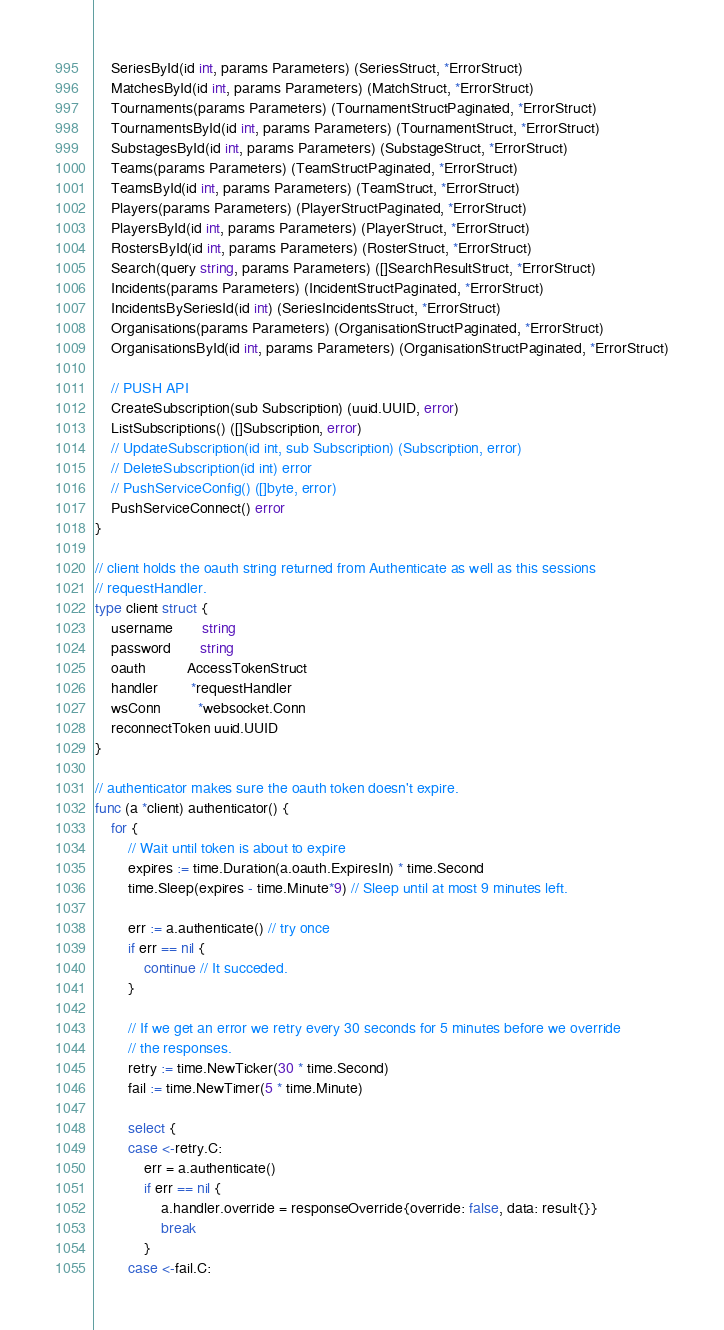<code> <loc_0><loc_0><loc_500><loc_500><_Go_>	SeriesById(id int, params Parameters) (SeriesStruct, *ErrorStruct)
	MatchesById(id int, params Parameters) (MatchStruct, *ErrorStruct)
	Tournaments(params Parameters) (TournamentStructPaginated, *ErrorStruct)
	TournamentsById(id int, params Parameters) (TournamentStruct, *ErrorStruct)
	SubstagesById(id int, params Parameters) (SubstageStruct, *ErrorStruct)
	Teams(params Parameters) (TeamStructPaginated, *ErrorStruct)
	TeamsById(id int, params Parameters) (TeamStruct, *ErrorStruct)
	Players(params Parameters) (PlayerStructPaginated, *ErrorStruct)
	PlayersById(id int, params Parameters) (PlayerStruct, *ErrorStruct)
	RostersById(id int, params Parameters) (RosterStruct, *ErrorStruct)
	Search(query string, params Parameters) ([]SearchResultStruct, *ErrorStruct)
	Incidents(params Parameters) (IncidentStructPaginated, *ErrorStruct)
	IncidentsBySeriesId(id int) (SeriesIncidentsStruct, *ErrorStruct)
	Organisations(params Parameters) (OrganisationStructPaginated, *ErrorStruct)
	OrganisationsById(id int, params Parameters) (OrganisationStructPaginated, *ErrorStruct)

	// PUSH API
	CreateSubscription(sub Subscription) (uuid.UUID, error)
	ListSubscriptions() ([]Subscription, error)
	// UpdateSubscription(id int, sub Subscription) (Subscription, error)
	// DeleteSubscription(id int) error
	// PushServiceConfig() ([]byte, error)
	PushServiceConnect() error
}

// client holds the oauth string returned from Authenticate as well as this sessions
// requestHandler.
type client struct {
	username       string
	password       string
	oauth          AccessTokenStruct
	handler        *requestHandler
	wsConn         *websocket.Conn
	reconnectToken uuid.UUID
}

// authenticator makes sure the oauth token doesn't expire.
func (a *client) authenticator() {
	for {
		// Wait until token is about to expire
		expires := time.Duration(a.oauth.ExpiresIn) * time.Second
		time.Sleep(expires - time.Minute*9) // Sleep until at most 9 minutes left.

		err := a.authenticate() // try once
		if err == nil {
			continue // It succeded.
		}

		// If we get an error we retry every 30 seconds for 5 minutes before we override
		// the responses.
		retry := time.NewTicker(30 * time.Second)
		fail := time.NewTimer(5 * time.Minute)

		select {
		case <-retry.C:
			err = a.authenticate()
			if err == nil {
				a.handler.override = responseOverride{override: false, data: result{}}
				break
			}
		case <-fail.C:</code> 